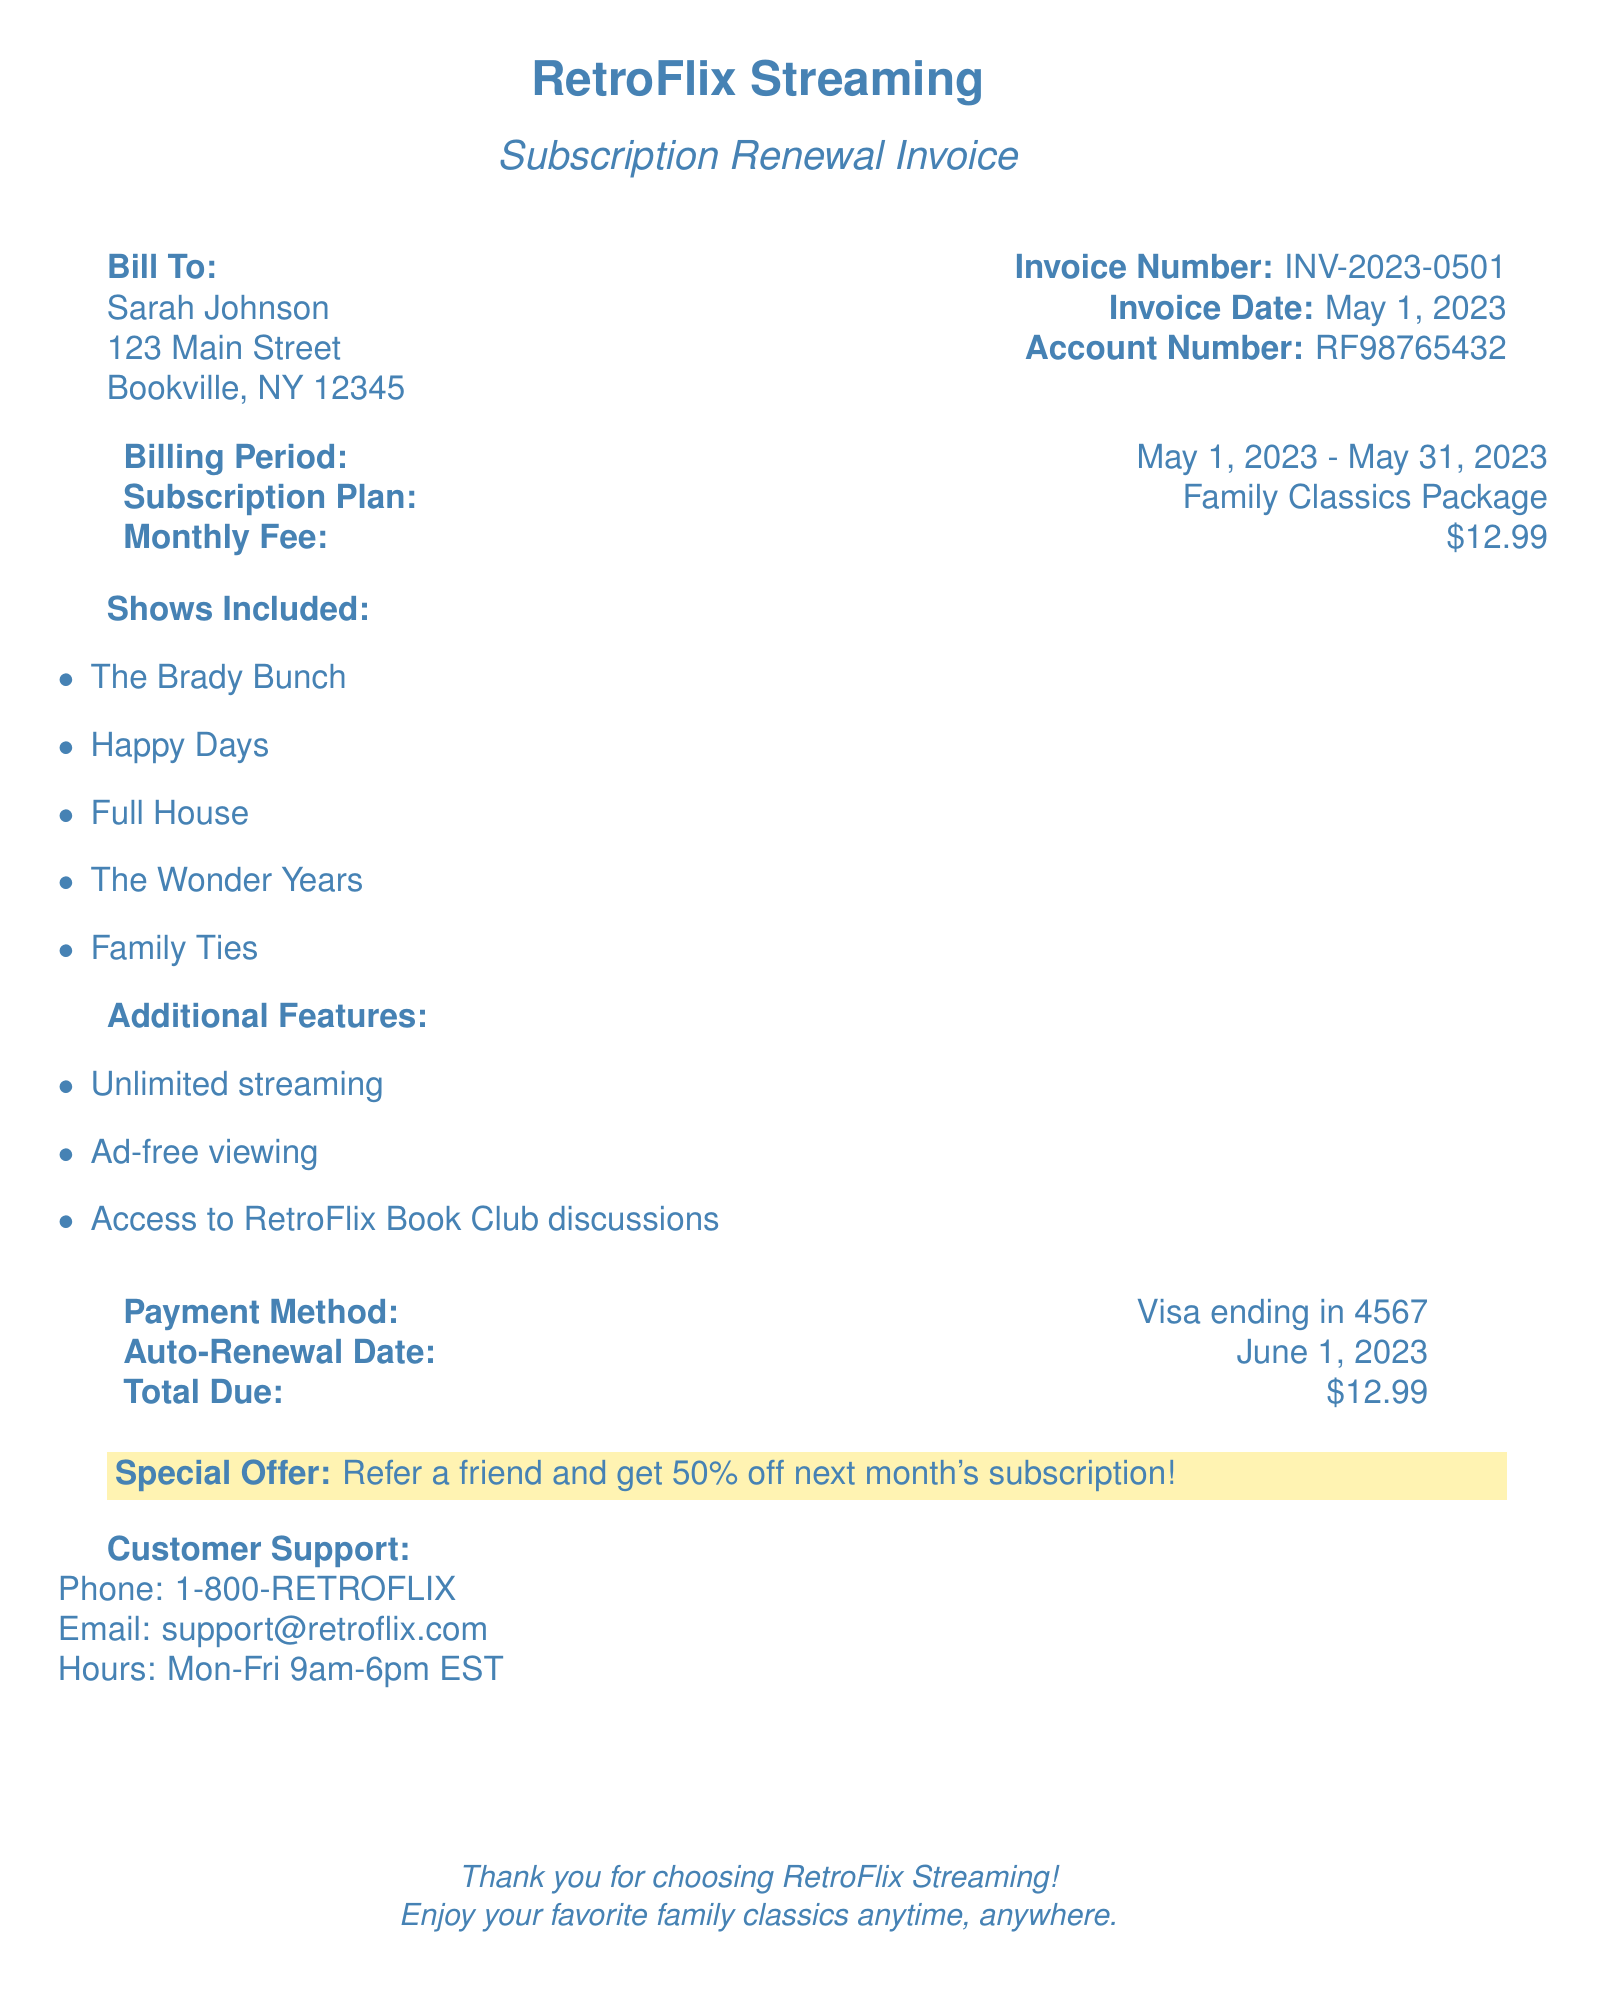What is the name of the streaming service? The name of the streaming service can be found at the top of the document as RetroFlix Streaming.
Answer: RetroFlix Streaming What is the invoice number? The invoice number is mentioned in the document under the section with invoice details.
Answer: INV-2023-0501 What is the monthly fee for the subscription? The monthly fee is listed in the billing details of the document.
Answer: $12.99 What is the billing period for this invoice? The billing period is indicated along with the subscription details in the document.
Answer: May 1, 2023 - May 31, 2023 What shows are included in the subscription? The document lists these shows in a bullet format.
Answer: The Brady Bunch, Happy Days, Full House, The Wonder Years, Family Ties What payment method is used for this subscription? The payment method is stated in the payment details section of the document.
Answer: Visa ending in 4567 On what date does the auto-renewal occur? The auto-renewal date is provided in the payment section of the document.
Answer: June 1, 2023 What special offer is provided in this invoice? The special offer is highlighted with a color background in the document.
Answer: Refer a friend and get 50% off next month's subscription! What type of subscription plan is mentioned? The subscription plan is noted in the billing details section of the document.
Answer: Family Classics Package 